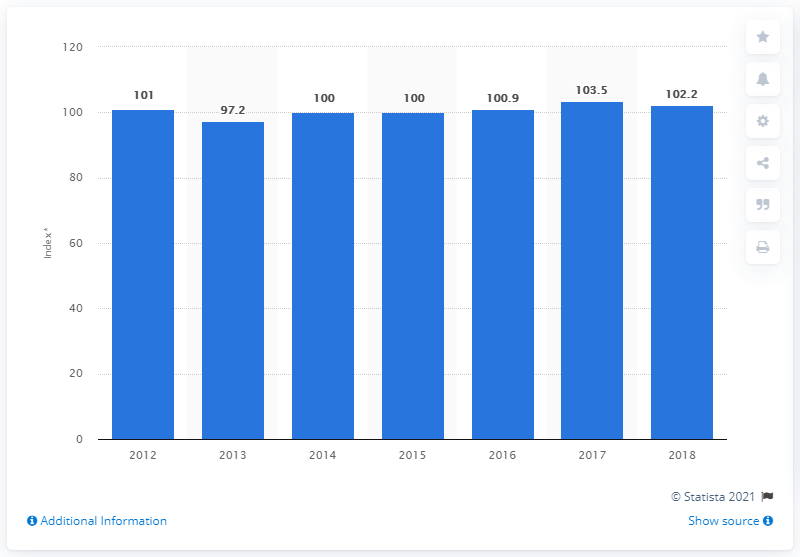Outline some significant characteristics in this image. The peak output index of manufacturing in 2017 was 103.5. In 2013, the index of manufacturing was 97.2. 